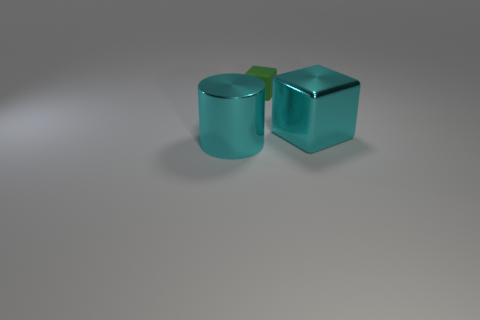What number of cylinders have the same size as the cyan metallic block?
Offer a terse response. 1. There is a cyan object that is on the left side of the cube that is on the right side of the small cube; how many green blocks are behind it?
Offer a terse response. 1. How many big cyan things are to the left of the large metallic block and to the right of the small matte cube?
Ensure brevity in your answer.  0. Is there anything else that is the same color as the large block?
Give a very brief answer. Yes. How many rubber things are tiny green things or big brown cylinders?
Your answer should be compact. 1. There is a cube that is behind the object on the right side of the thing that is behind the shiny cube; what is it made of?
Provide a short and direct response. Rubber. What material is the large cyan object that is in front of the big thing on the right side of the cylinder?
Ensure brevity in your answer.  Metal. Do the shiny thing that is behind the cyan metallic cylinder and the thing left of the small green thing have the same size?
Your response must be concise. Yes. Is there any other thing that has the same material as the tiny object?
Keep it short and to the point. No. How many large objects are either cyan things or green matte blocks?
Keep it short and to the point. 2. 